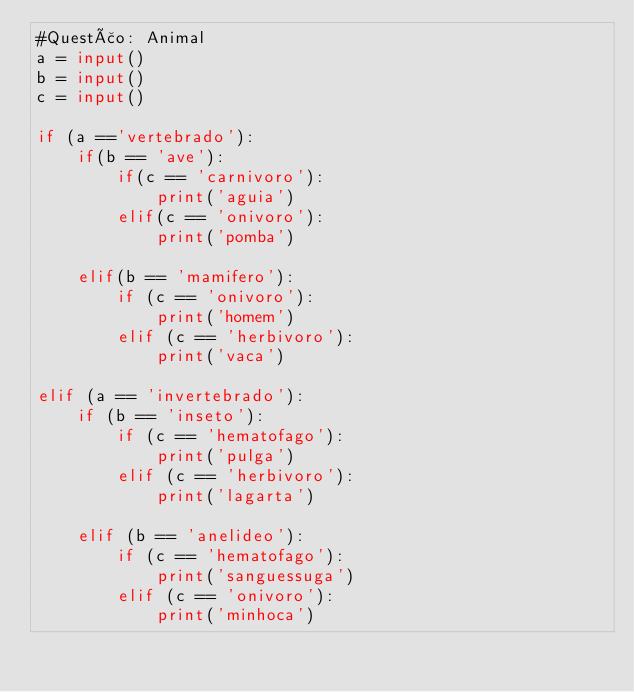<code> <loc_0><loc_0><loc_500><loc_500><_Python_>#Questão: Animal
a = input()
b = input()
c = input()

if (a =='vertebrado'):
    if(b == 'ave'):
        if(c == 'carnivoro'):
            print('aguia')
        elif(c == 'onivoro'):
            print('pomba')

    elif(b == 'mamifero'):
        if (c == 'onivoro'):
            print('homem')
        elif (c == 'herbivoro'):
            print('vaca')

elif (a == 'invertebrado'):
    if (b == 'inseto'):
        if (c == 'hematofago'):
            print('pulga')
        elif (c == 'herbivoro'):
            print('lagarta')

    elif (b == 'anelideo'):
        if (c == 'hematofago'):
            print('sanguessuga')
        elif (c == 'onivoro'):
            print('minhoca')</code> 